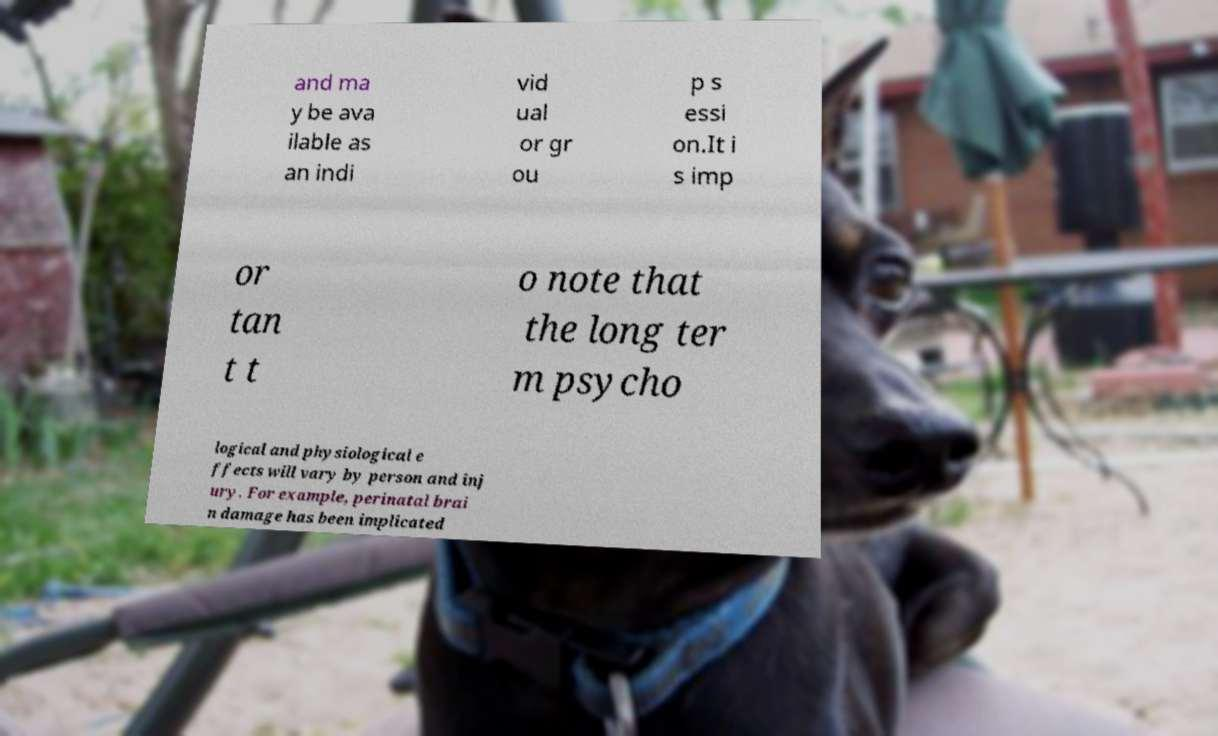Please read and relay the text visible in this image. What does it say? and ma y be ava ilable as an indi vid ual or gr ou p s essi on.It i s imp or tan t t o note that the long ter m psycho logical and physiological e ffects will vary by person and inj ury. For example, perinatal brai n damage has been implicated 